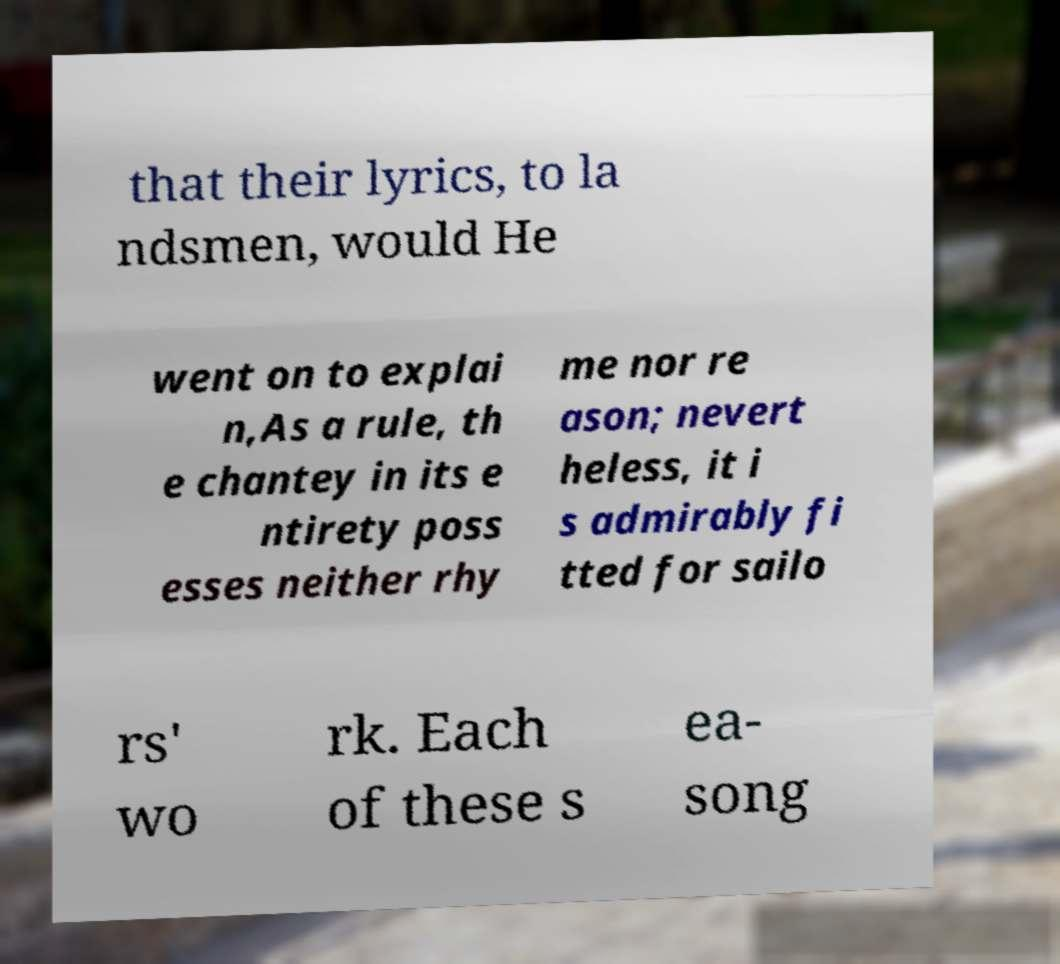Please identify and transcribe the text found in this image. that their lyrics, to la ndsmen, would He went on to explai n,As a rule, th e chantey in its e ntirety poss esses neither rhy me nor re ason; nevert heless, it i s admirably fi tted for sailo rs' wo rk. Each of these s ea- song 